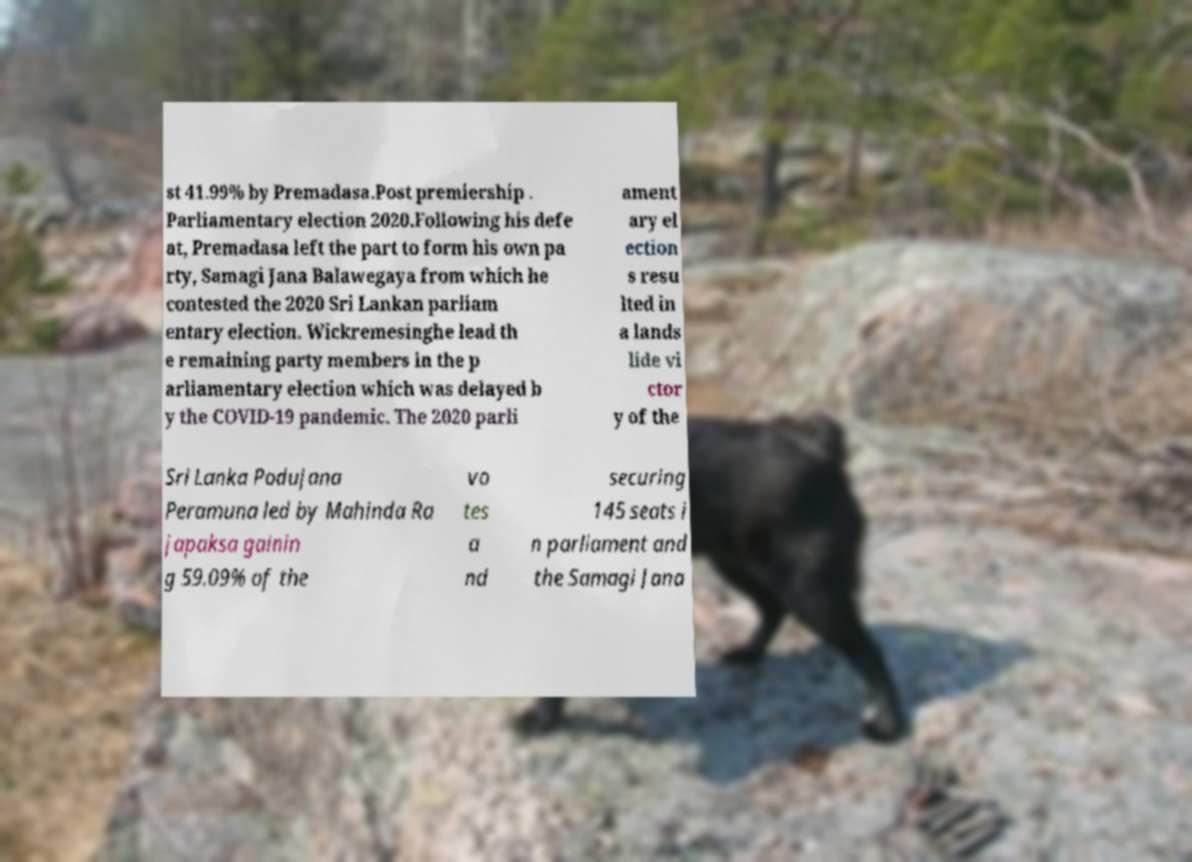For documentation purposes, I need the text within this image transcribed. Could you provide that? st 41.99% by Premadasa.Post premiership . Parliamentary election 2020.Following his defe at, Premadasa left the part to form his own pa rty, Samagi Jana Balawegaya from which he contested the 2020 Sri Lankan parliam entary election. Wickremesinghe lead th e remaining party members in the p arliamentary election which was delayed b y the COVID-19 pandemic. The 2020 parli ament ary el ection s resu lted in a lands lide vi ctor y of the Sri Lanka Podujana Peramuna led by Mahinda Ra japaksa gainin g 59.09% of the vo tes a nd securing 145 seats i n parliament and the Samagi Jana 